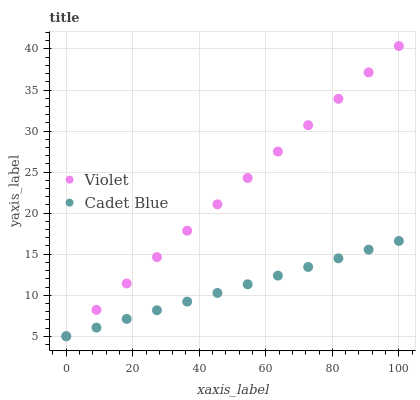Does Cadet Blue have the minimum area under the curve?
Answer yes or no. Yes. Does Violet have the maximum area under the curve?
Answer yes or no. Yes. Does Violet have the minimum area under the curve?
Answer yes or no. No. Is Cadet Blue the smoothest?
Answer yes or no. Yes. Is Violet the roughest?
Answer yes or no. Yes. Is Violet the smoothest?
Answer yes or no. No. Does Cadet Blue have the lowest value?
Answer yes or no. Yes. Does Violet have the highest value?
Answer yes or no. Yes. Does Violet intersect Cadet Blue?
Answer yes or no. Yes. Is Violet less than Cadet Blue?
Answer yes or no. No. Is Violet greater than Cadet Blue?
Answer yes or no. No. 